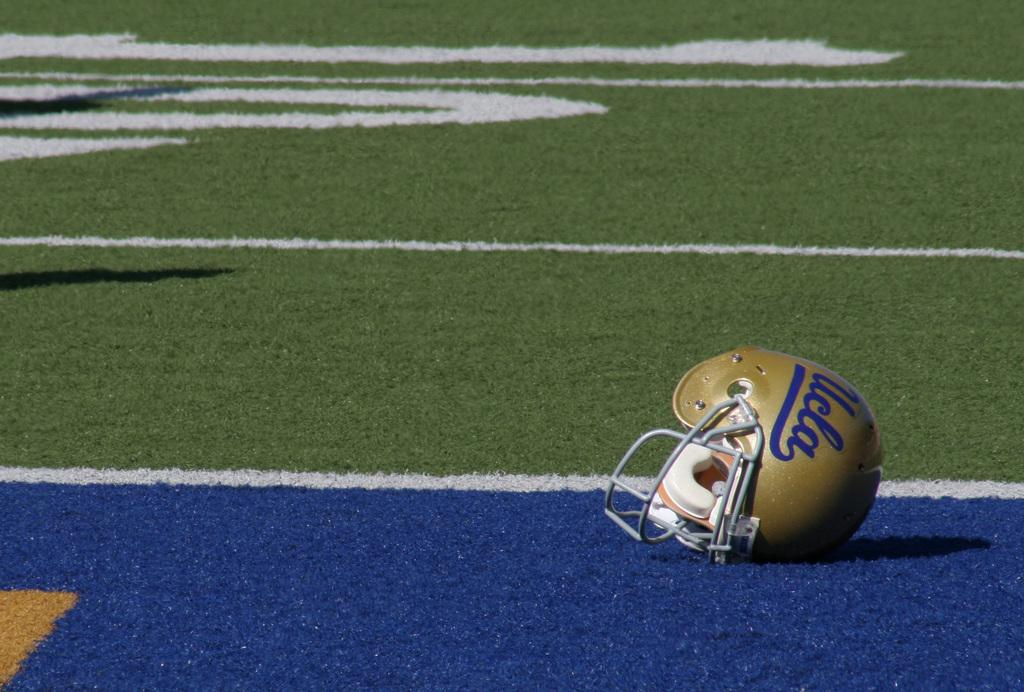What object is on the ground in the image? There is a helmet on the ground in the image. What can be seen on the ground besides the helmet? White lines and numbers are visible on the ground. What colors are present on the ground? The ground has blue and yellow colors. What type of behavior can be observed through the window in the image? There is no window present in the image, so it is not possible to observe any behavior through a window. 